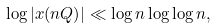<formula> <loc_0><loc_0><loc_500><loc_500>\log | x ( n Q ) | \ll \log n \log \log n ,</formula> 